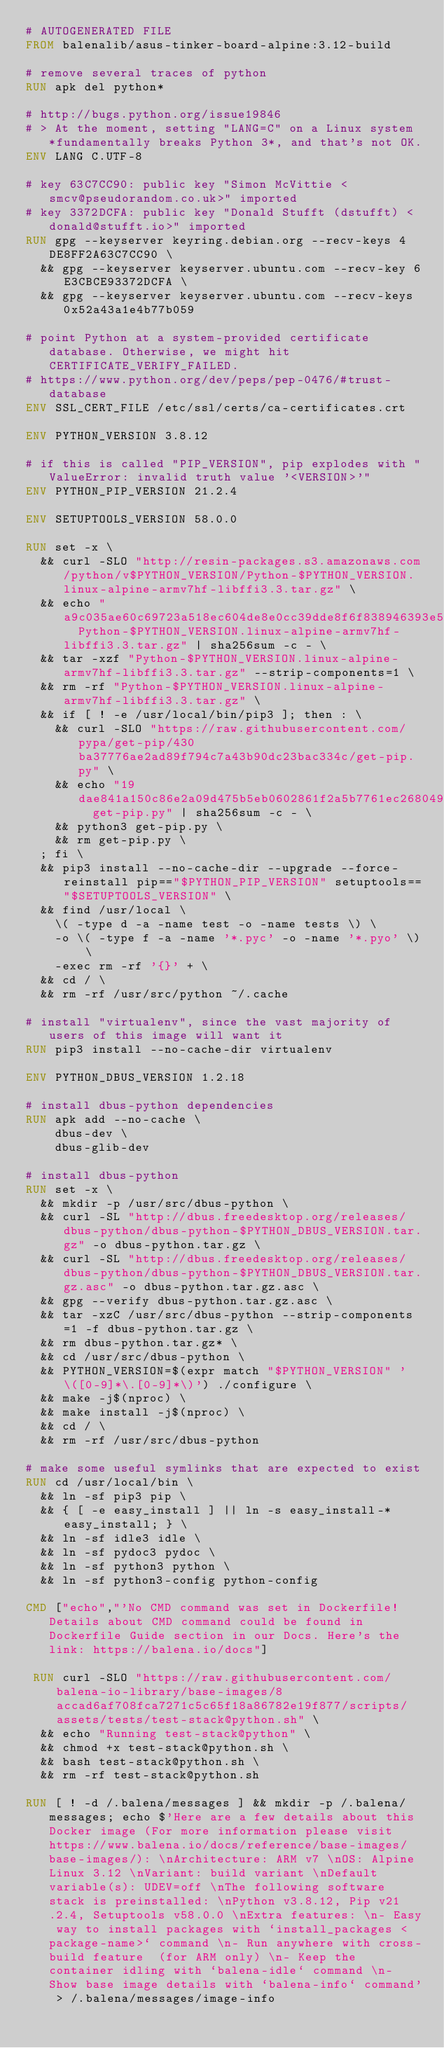<code> <loc_0><loc_0><loc_500><loc_500><_Dockerfile_># AUTOGENERATED FILE
FROM balenalib/asus-tinker-board-alpine:3.12-build

# remove several traces of python
RUN apk del python*

# http://bugs.python.org/issue19846
# > At the moment, setting "LANG=C" on a Linux system *fundamentally breaks Python 3*, and that's not OK.
ENV LANG C.UTF-8

# key 63C7CC90: public key "Simon McVittie <smcv@pseudorandom.co.uk>" imported
# key 3372DCFA: public key "Donald Stufft (dstufft) <donald@stufft.io>" imported
RUN gpg --keyserver keyring.debian.org --recv-keys 4DE8FF2A63C7CC90 \
	&& gpg --keyserver keyserver.ubuntu.com --recv-key 6E3CBCE93372DCFA \
	&& gpg --keyserver keyserver.ubuntu.com --recv-keys 0x52a43a1e4b77b059

# point Python at a system-provided certificate database. Otherwise, we might hit CERTIFICATE_VERIFY_FAILED.
# https://www.python.org/dev/peps/pep-0476/#trust-database
ENV SSL_CERT_FILE /etc/ssl/certs/ca-certificates.crt

ENV PYTHON_VERSION 3.8.12

# if this is called "PIP_VERSION", pip explodes with "ValueError: invalid truth value '<VERSION>'"
ENV PYTHON_PIP_VERSION 21.2.4

ENV SETUPTOOLS_VERSION 58.0.0

RUN set -x \
	&& curl -SLO "http://resin-packages.s3.amazonaws.com/python/v$PYTHON_VERSION/Python-$PYTHON_VERSION.linux-alpine-armv7hf-libffi3.3.tar.gz" \
	&& echo "a9c035ae60c69723a518ec604de8e0cc39dde8f6f838946393e5999c9cdf3cba  Python-$PYTHON_VERSION.linux-alpine-armv7hf-libffi3.3.tar.gz" | sha256sum -c - \
	&& tar -xzf "Python-$PYTHON_VERSION.linux-alpine-armv7hf-libffi3.3.tar.gz" --strip-components=1 \
	&& rm -rf "Python-$PYTHON_VERSION.linux-alpine-armv7hf-libffi3.3.tar.gz" \
	&& if [ ! -e /usr/local/bin/pip3 ]; then : \
		&& curl -SLO "https://raw.githubusercontent.com/pypa/get-pip/430ba37776ae2ad89f794c7a43b90dc23bac334c/get-pip.py" \
		&& echo "19dae841a150c86e2a09d475b5eb0602861f2a5b7761ec268049a662dbd2bd0c  get-pip.py" | sha256sum -c - \
		&& python3 get-pip.py \
		&& rm get-pip.py \
	; fi \
	&& pip3 install --no-cache-dir --upgrade --force-reinstall pip=="$PYTHON_PIP_VERSION" setuptools=="$SETUPTOOLS_VERSION" \
	&& find /usr/local \
		\( -type d -a -name test -o -name tests \) \
		-o \( -type f -a -name '*.pyc' -o -name '*.pyo' \) \
		-exec rm -rf '{}' + \
	&& cd / \
	&& rm -rf /usr/src/python ~/.cache

# install "virtualenv", since the vast majority of users of this image will want it
RUN pip3 install --no-cache-dir virtualenv

ENV PYTHON_DBUS_VERSION 1.2.18

# install dbus-python dependencies 
RUN apk add --no-cache \
		dbus-dev \
		dbus-glib-dev

# install dbus-python
RUN set -x \
	&& mkdir -p /usr/src/dbus-python \
	&& curl -SL "http://dbus.freedesktop.org/releases/dbus-python/dbus-python-$PYTHON_DBUS_VERSION.tar.gz" -o dbus-python.tar.gz \
	&& curl -SL "http://dbus.freedesktop.org/releases/dbus-python/dbus-python-$PYTHON_DBUS_VERSION.tar.gz.asc" -o dbus-python.tar.gz.asc \
	&& gpg --verify dbus-python.tar.gz.asc \
	&& tar -xzC /usr/src/dbus-python --strip-components=1 -f dbus-python.tar.gz \
	&& rm dbus-python.tar.gz* \
	&& cd /usr/src/dbus-python \
	&& PYTHON_VERSION=$(expr match "$PYTHON_VERSION" '\([0-9]*\.[0-9]*\)') ./configure \
	&& make -j$(nproc) \
	&& make install -j$(nproc) \
	&& cd / \
	&& rm -rf /usr/src/dbus-python

# make some useful symlinks that are expected to exist
RUN cd /usr/local/bin \
	&& ln -sf pip3 pip \
	&& { [ -e easy_install ] || ln -s easy_install-* easy_install; } \
	&& ln -sf idle3 idle \
	&& ln -sf pydoc3 pydoc \
	&& ln -sf python3 python \
	&& ln -sf python3-config python-config

CMD ["echo","'No CMD command was set in Dockerfile! Details about CMD command could be found in Dockerfile Guide section in our Docs. Here's the link: https://balena.io/docs"]

 RUN curl -SLO "https://raw.githubusercontent.com/balena-io-library/base-images/8accad6af708fca7271c5c65f18a86782e19f877/scripts/assets/tests/test-stack@python.sh" \
  && echo "Running test-stack@python" \
  && chmod +x test-stack@python.sh \
  && bash test-stack@python.sh \
  && rm -rf test-stack@python.sh 

RUN [ ! -d /.balena/messages ] && mkdir -p /.balena/messages; echo $'Here are a few details about this Docker image (For more information please visit https://www.balena.io/docs/reference/base-images/base-images/): \nArchitecture: ARM v7 \nOS: Alpine Linux 3.12 \nVariant: build variant \nDefault variable(s): UDEV=off \nThe following software stack is preinstalled: \nPython v3.8.12, Pip v21.2.4, Setuptools v58.0.0 \nExtra features: \n- Easy way to install packages with `install_packages <package-name>` command \n- Run anywhere with cross-build feature  (for ARM only) \n- Keep the container idling with `balena-idle` command \n- Show base image details with `balena-info` command' > /.balena/messages/image-info
</code> 